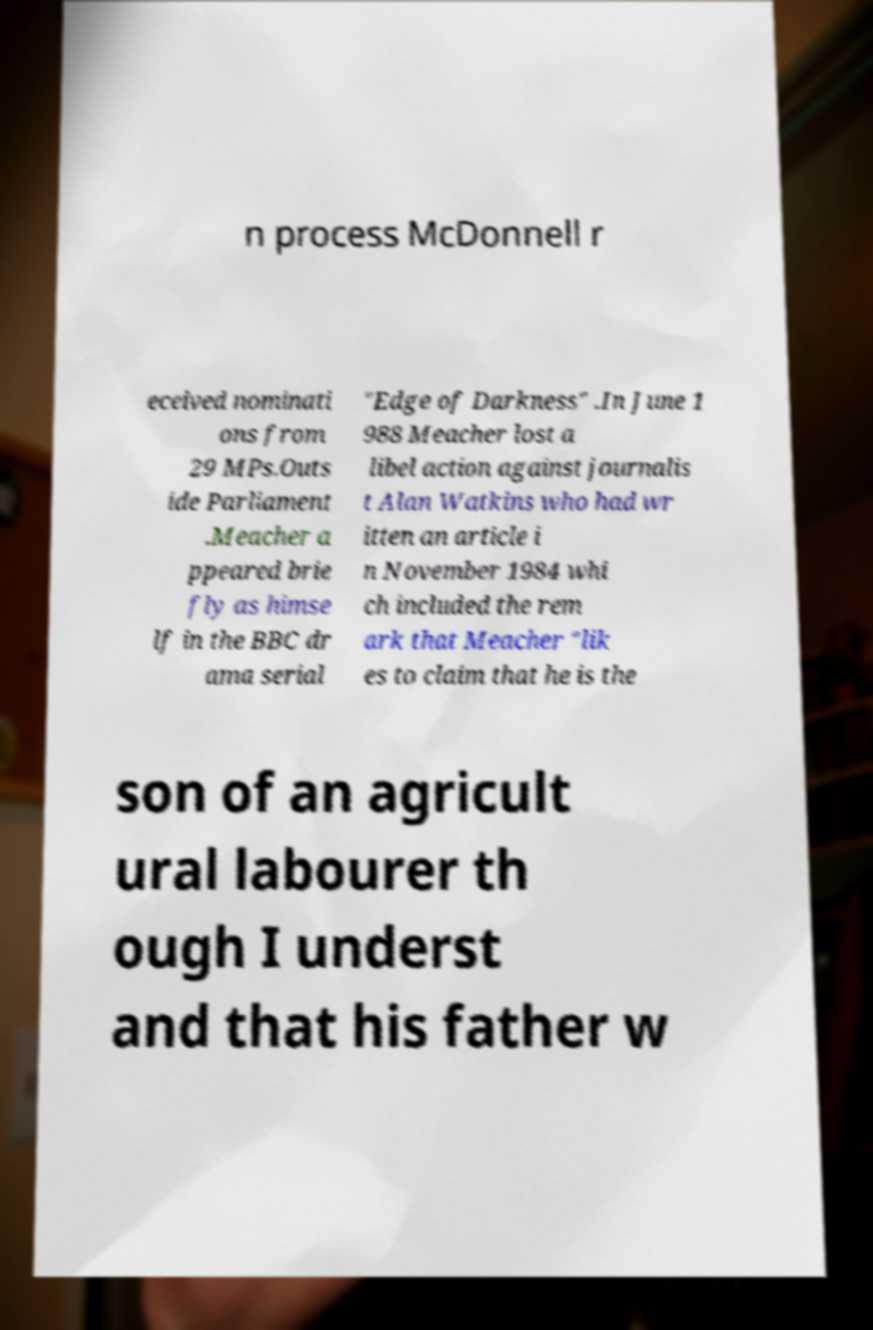Please read and relay the text visible in this image. What does it say? n process McDonnell r eceived nominati ons from 29 MPs.Outs ide Parliament .Meacher a ppeared brie fly as himse lf in the BBC dr ama serial "Edge of Darkness" .In June 1 988 Meacher lost a libel action against journalis t Alan Watkins who had wr itten an article i n November 1984 whi ch included the rem ark that Meacher "lik es to claim that he is the son of an agricult ural labourer th ough I underst and that his father w 